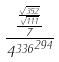<formula> <loc_0><loc_0><loc_500><loc_500>\frac { \frac { \frac { \sqrt { 3 5 2 } } { \sqrt { 1 1 1 } } } { 7 } } { { 4 ^ { 3 3 6 } } ^ { 2 9 4 } }</formula> 